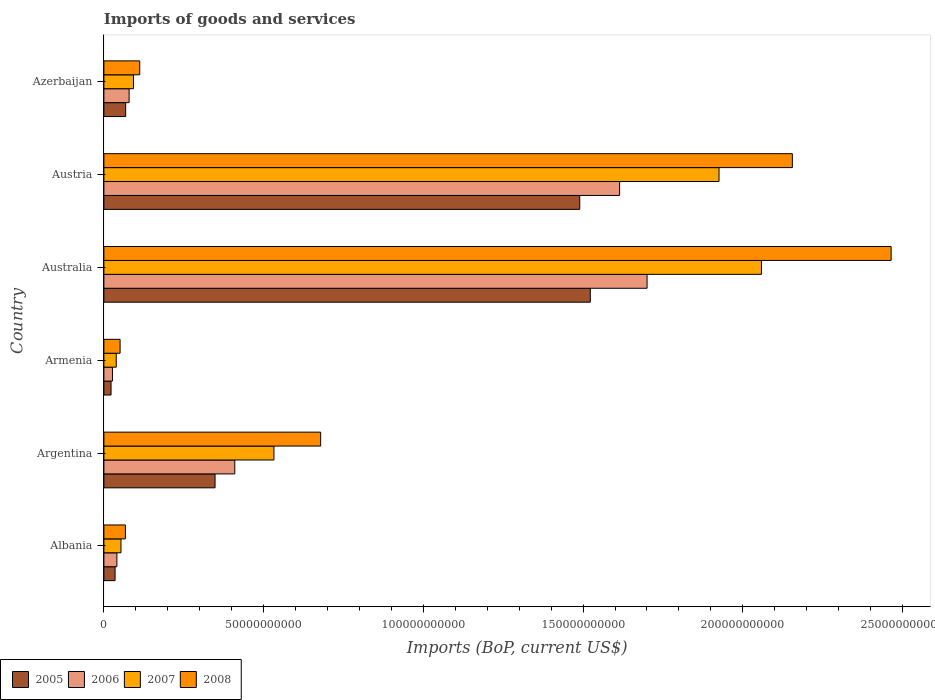How many different coloured bars are there?
Offer a very short reply. 4. How many groups of bars are there?
Offer a terse response. 6. Are the number of bars per tick equal to the number of legend labels?
Keep it short and to the point. Yes. Are the number of bars on each tick of the Y-axis equal?
Your answer should be very brief. Yes. How many bars are there on the 6th tick from the top?
Ensure brevity in your answer.  4. What is the label of the 4th group of bars from the top?
Make the answer very short. Armenia. In how many cases, is the number of bars for a given country not equal to the number of legend labels?
Provide a succinct answer. 0. What is the amount spent on imports in 2007 in Albania?
Make the answer very short. 5.34e+09. Across all countries, what is the maximum amount spent on imports in 2006?
Keep it short and to the point. 1.70e+11. Across all countries, what is the minimum amount spent on imports in 2005?
Keep it short and to the point. 2.24e+09. In which country was the amount spent on imports in 2005 minimum?
Make the answer very short. Armenia. What is the total amount spent on imports in 2007 in the graph?
Offer a terse response. 4.70e+11. What is the difference between the amount spent on imports in 2008 in Australia and that in Austria?
Provide a short and direct response. 3.09e+1. What is the difference between the amount spent on imports in 2005 in Azerbaijan and the amount spent on imports in 2007 in Armenia?
Your answer should be compact. 2.94e+09. What is the average amount spent on imports in 2007 per country?
Your answer should be very brief. 7.83e+1. What is the difference between the amount spent on imports in 2008 and amount spent on imports in 2007 in Azerbaijan?
Your response must be concise. 1.96e+09. What is the ratio of the amount spent on imports in 2005 in Albania to that in Armenia?
Your answer should be very brief. 1.56. What is the difference between the highest and the second highest amount spent on imports in 2006?
Offer a very short reply. 8.59e+09. What is the difference between the highest and the lowest amount spent on imports in 2007?
Provide a succinct answer. 2.02e+11. In how many countries, is the amount spent on imports in 2006 greater than the average amount spent on imports in 2006 taken over all countries?
Offer a very short reply. 2. Is the sum of the amount spent on imports in 2008 in Argentina and Armenia greater than the maximum amount spent on imports in 2007 across all countries?
Provide a succinct answer. No. Is it the case that in every country, the sum of the amount spent on imports in 2007 and amount spent on imports in 2008 is greater than the sum of amount spent on imports in 2006 and amount spent on imports in 2005?
Your answer should be very brief. No. What does the 2nd bar from the top in Albania represents?
Your answer should be very brief. 2007. Is it the case that in every country, the sum of the amount spent on imports in 2005 and amount spent on imports in 2007 is greater than the amount spent on imports in 2006?
Keep it short and to the point. Yes. Are all the bars in the graph horizontal?
Keep it short and to the point. Yes. Where does the legend appear in the graph?
Your response must be concise. Bottom left. What is the title of the graph?
Make the answer very short. Imports of goods and services. Does "1963" appear as one of the legend labels in the graph?
Your response must be concise. No. What is the label or title of the X-axis?
Provide a short and direct response. Imports (BoP, current US$). What is the label or title of the Y-axis?
Provide a short and direct response. Country. What is the Imports (BoP, current US$) in 2005 in Albania?
Keep it short and to the point. 3.50e+09. What is the Imports (BoP, current US$) in 2006 in Albania?
Ensure brevity in your answer.  4.07e+09. What is the Imports (BoP, current US$) of 2007 in Albania?
Provide a succinct answer. 5.34e+09. What is the Imports (BoP, current US$) in 2008 in Albania?
Provide a short and direct response. 6.73e+09. What is the Imports (BoP, current US$) of 2005 in Argentina?
Your answer should be compact. 3.48e+1. What is the Imports (BoP, current US$) of 2006 in Argentina?
Ensure brevity in your answer.  4.10e+1. What is the Imports (BoP, current US$) in 2007 in Argentina?
Give a very brief answer. 5.32e+1. What is the Imports (BoP, current US$) in 2008 in Argentina?
Offer a very short reply. 6.79e+1. What is the Imports (BoP, current US$) of 2005 in Armenia?
Keep it short and to the point. 2.24e+09. What is the Imports (BoP, current US$) in 2006 in Armenia?
Your response must be concise. 2.68e+09. What is the Imports (BoP, current US$) of 2007 in Armenia?
Ensure brevity in your answer.  3.88e+09. What is the Imports (BoP, current US$) in 2008 in Armenia?
Provide a succinct answer. 5.07e+09. What is the Imports (BoP, current US$) in 2005 in Australia?
Make the answer very short. 1.52e+11. What is the Imports (BoP, current US$) in 2006 in Australia?
Give a very brief answer. 1.70e+11. What is the Imports (BoP, current US$) in 2007 in Australia?
Provide a short and direct response. 2.06e+11. What is the Imports (BoP, current US$) of 2008 in Australia?
Offer a terse response. 2.46e+11. What is the Imports (BoP, current US$) in 2005 in Austria?
Your answer should be very brief. 1.49e+11. What is the Imports (BoP, current US$) in 2006 in Austria?
Your answer should be very brief. 1.61e+11. What is the Imports (BoP, current US$) of 2007 in Austria?
Offer a very short reply. 1.93e+11. What is the Imports (BoP, current US$) of 2008 in Austria?
Make the answer very short. 2.16e+11. What is the Imports (BoP, current US$) of 2005 in Azerbaijan?
Offer a very short reply. 6.81e+09. What is the Imports (BoP, current US$) of 2006 in Azerbaijan?
Offer a very short reply. 7.89e+09. What is the Imports (BoP, current US$) in 2007 in Azerbaijan?
Your response must be concise. 9.26e+09. What is the Imports (BoP, current US$) in 2008 in Azerbaijan?
Make the answer very short. 1.12e+1. Across all countries, what is the maximum Imports (BoP, current US$) of 2005?
Make the answer very short. 1.52e+11. Across all countries, what is the maximum Imports (BoP, current US$) in 2006?
Ensure brevity in your answer.  1.70e+11. Across all countries, what is the maximum Imports (BoP, current US$) in 2007?
Your answer should be compact. 2.06e+11. Across all countries, what is the maximum Imports (BoP, current US$) in 2008?
Your response must be concise. 2.46e+11. Across all countries, what is the minimum Imports (BoP, current US$) of 2005?
Provide a short and direct response. 2.24e+09. Across all countries, what is the minimum Imports (BoP, current US$) of 2006?
Offer a terse response. 2.68e+09. Across all countries, what is the minimum Imports (BoP, current US$) of 2007?
Ensure brevity in your answer.  3.88e+09. Across all countries, what is the minimum Imports (BoP, current US$) of 2008?
Offer a terse response. 5.07e+09. What is the total Imports (BoP, current US$) of 2005 in the graph?
Keep it short and to the point. 3.49e+11. What is the total Imports (BoP, current US$) in 2006 in the graph?
Offer a very short reply. 3.87e+11. What is the total Imports (BoP, current US$) of 2007 in the graph?
Ensure brevity in your answer.  4.70e+11. What is the total Imports (BoP, current US$) of 2008 in the graph?
Your response must be concise. 5.53e+11. What is the difference between the Imports (BoP, current US$) of 2005 in Albania and that in Argentina?
Your answer should be compact. -3.13e+1. What is the difference between the Imports (BoP, current US$) of 2006 in Albania and that in Argentina?
Ensure brevity in your answer.  -3.69e+1. What is the difference between the Imports (BoP, current US$) in 2007 in Albania and that in Argentina?
Your answer should be compact. -4.79e+1. What is the difference between the Imports (BoP, current US$) of 2008 in Albania and that in Argentina?
Your answer should be compact. -6.11e+1. What is the difference between the Imports (BoP, current US$) in 2005 in Albania and that in Armenia?
Your response must be concise. 1.26e+09. What is the difference between the Imports (BoP, current US$) in 2006 in Albania and that in Armenia?
Keep it short and to the point. 1.39e+09. What is the difference between the Imports (BoP, current US$) in 2007 in Albania and that in Armenia?
Offer a very short reply. 1.47e+09. What is the difference between the Imports (BoP, current US$) in 2008 in Albania and that in Armenia?
Make the answer very short. 1.66e+09. What is the difference between the Imports (BoP, current US$) of 2005 in Albania and that in Australia?
Give a very brief answer. -1.49e+11. What is the difference between the Imports (BoP, current US$) of 2006 in Albania and that in Australia?
Ensure brevity in your answer.  -1.66e+11. What is the difference between the Imports (BoP, current US$) of 2007 in Albania and that in Australia?
Your response must be concise. -2.00e+11. What is the difference between the Imports (BoP, current US$) in 2008 in Albania and that in Australia?
Provide a short and direct response. -2.40e+11. What is the difference between the Imports (BoP, current US$) in 2005 in Albania and that in Austria?
Your answer should be compact. -1.45e+11. What is the difference between the Imports (BoP, current US$) of 2006 in Albania and that in Austria?
Give a very brief answer. -1.57e+11. What is the difference between the Imports (BoP, current US$) in 2007 in Albania and that in Austria?
Provide a succinct answer. -1.87e+11. What is the difference between the Imports (BoP, current US$) in 2008 in Albania and that in Austria?
Your answer should be compact. -2.09e+11. What is the difference between the Imports (BoP, current US$) in 2005 in Albania and that in Azerbaijan?
Ensure brevity in your answer.  -3.31e+09. What is the difference between the Imports (BoP, current US$) of 2006 in Albania and that in Azerbaijan?
Keep it short and to the point. -3.82e+09. What is the difference between the Imports (BoP, current US$) of 2007 in Albania and that in Azerbaijan?
Offer a terse response. -3.92e+09. What is the difference between the Imports (BoP, current US$) of 2008 in Albania and that in Azerbaijan?
Give a very brief answer. -4.49e+09. What is the difference between the Imports (BoP, current US$) in 2005 in Argentina and that in Armenia?
Provide a short and direct response. 3.26e+1. What is the difference between the Imports (BoP, current US$) in 2006 in Argentina and that in Armenia?
Give a very brief answer. 3.83e+1. What is the difference between the Imports (BoP, current US$) of 2007 in Argentina and that in Armenia?
Provide a succinct answer. 4.94e+1. What is the difference between the Imports (BoP, current US$) in 2008 in Argentina and that in Armenia?
Offer a very short reply. 6.28e+1. What is the difference between the Imports (BoP, current US$) in 2005 in Argentina and that in Australia?
Provide a short and direct response. -1.17e+11. What is the difference between the Imports (BoP, current US$) in 2006 in Argentina and that in Australia?
Your answer should be very brief. -1.29e+11. What is the difference between the Imports (BoP, current US$) in 2007 in Argentina and that in Australia?
Your response must be concise. -1.53e+11. What is the difference between the Imports (BoP, current US$) of 2008 in Argentina and that in Australia?
Your response must be concise. -1.79e+11. What is the difference between the Imports (BoP, current US$) of 2005 in Argentina and that in Austria?
Provide a succinct answer. -1.14e+11. What is the difference between the Imports (BoP, current US$) of 2006 in Argentina and that in Austria?
Keep it short and to the point. -1.20e+11. What is the difference between the Imports (BoP, current US$) in 2007 in Argentina and that in Austria?
Your response must be concise. -1.39e+11. What is the difference between the Imports (BoP, current US$) in 2008 in Argentina and that in Austria?
Offer a very short reply. -1.48e+11. What is the difference between the Imports (BoP, current US$) in 2005 in Argentina and that in Azerbaijan?
Your response must be concise. 2.80e+1. What is the difference between the Imports (BoP, current US$) of 2006 in Argentina and that in Azerbaijan?
Give a very brief answer. 3.31e+1. What is the difference between the Imports (BoP, current US$) in 2007 in Argentina and that in Azerbaijan?
Keep it short and to the point. 4.40e+1. What is the difference between the Imports (BoP, current US$) of 2008 in Argentina and that in Azerbaijan?
Keep it short and to the point. 5.66e+1. What is the difference between the Imports (BoP, current US$) of 2005 in Armenia and that in Australia?
Provide a succinct answer. -1.50e+11. What is the difference between the Imports (BoP, current US$) of 2006 in Armenia and that in Australia?
Offer a very short reply. -1.67e+11. What is the difference between the Imports (BoP, current US$) in 2007 in Armenia and that in Australia?
Keep it short and to the point. -2.02e+11. What is the difference between the Imports (BoP, current US$) in 2008 in Armenia and that in Australia?
Provide a short and direct response. -2.41e+11. What is the difference between the Imports (BoP, current US$) in 2005 in Armenia and that in Austria?
Offer a very short reply. -1.47e+11. What is the difference between the Imports (BoP, current US$) of 2006 in Armenia and that in Austria?
Ensure brevity in your answer.  -1.59e+11. What is the difference between the Imports (BoP, current US$) of 2007 in Armenia and that in Austria?
Your response must be concise. -1.89e+11. What is the difference between the Imports (BoP, current US$) of 2008 in Armenia and that in Austria?
Provide a succinct answer. -2.10e+11. What is the difference between the Imports (BoP, current US$) in 2005 in Armenia and that in Azerbaijan?
Give a very brief answer. -4.57e+09. What is the difference between the Imports (BoP, current US$) of 2006 in Armenia and that in Azerbaijan?
Your answer should be very brief. -5.21e+09. What is the difference between the Imports (BoP, current US$) in 2007 in Armenia and that in Azerbaijan?
Provide a succinct answer. -5.39e+09. What is the difference between the Imports (BoP, current US$) of 2008 in Armenia and that in Azerbaijan?
Offer a very short reply. -6.15e+09. What is the difference between the Imports (BoP, current US$) in 2005 in Australia and that in Austria?
Your answer should be very brief. 3.31e+09. What is the difference between the Imports (BoP, current US$) of 2006 in Australia and that in Austria?
Offer a terse response. 8.59e+09. What is the difference between the Imports (BoP, current US$) of 2007 in Australia and that in Austria?
Make the answer very short. 1.33e+1. What is the difference between the Imports (BoP, current US$) of 2008 in Australia and that in Austria?
Offer a very short reply. 3.09e+1. What is the difference between the Imports (BoP, current US$) of 2005 in Australia and that in Azerbaijan?
Ensure brevity in your answer.  1.45e+11. What is the difference between the Imports (BoP, current US$) in 2006 in Australia and that in Azerbaijan?
Your answer should be very brief. 1.62e+11. What is the difference between the Imports (BoP, current US$) in 2007 in Australia and that in Azerbaijan?
Offer a terse response. 1.97e+11. What is the difference between the Imports (BoP, current US$) in 2008 in Australia and that in Azerbaijan?
Offer a very short reply. 2.35e+11. What is the difference between the Imports (BoP, current US$) of 2005 in Austria and that in Azerbaijan?
Ensure brevity in your answer.  1.42e+11. What is the difference between the Imports (BoP, current US$) of 2006 in Austria and that in Azerbaijan?
Your answer should be compact. 1.54e+11. What is the difference between the Imports (BoP, current US$) in 2007 in Austria and that in Azerbaijan?
Your answer should be compact. 1.83e+11. What is the difference between the Imports (BoP, current US$) in 2008 in Austria and that in Azerbaijan?
Offer a terse response. 2.04e+11. What is the difference between the Imports (BoP, current US$) in 2005 in Albania and the Imports (BoP, current US$) in 2006 in Argentina?
Give a very brief answer. -3.75e+1. What is the difference between the Imports (BoP, current US$) in 2005 in Albania and the Imports (BoP, current US$) in 2007 in Argentina?
Provide a short and direct response. -4.97e+1. What is the difference between the Imports (BoP, current US$) in 2005 in Albania and the Imports (BoP, current US$) in 2008 in Argentina?
Provide a succinct answer. -6.43e+1. What is the difference between the Imports (BoP, current US$) of 2006 in Albania and the Imports (BoP, current US$) of 2007 in Argentina?
Keep it short and to the point. -4.92e+1. What is the difference between the Imports (BoP, current US$) in 2006 in Albania and the Imports (BoP, current US$) in 2008 in Argentina?
Your answer should be compact. -6.38e+1. What is the difference between the Imports (BoP, current US$) in 2007 in Albania and the Imports (BoP, current US$) in 2008 in Argentina?
Provide a short and direct response. -6.25e+1. What is the difference between the Imports (BoP, current US$) in 2005 in Albania and the Imports (BoP, current US$) in 2006 in Armenia?
Ensure brevity in your answer.  8.18e+08. What is the difference between the Imports (BoP, current US$) of 2005 in Albania and the Imports (BoP, current US$) of 2007 in Armenia?
Your answer should be very brief. -3.75e+08. What is the difference between the Imports (BoP, current US$) of 2005 in Albania and the Imports (BoP, current US$) of 2008 in Armenia?
Offer a very short reply. -1.57e+09. What is the difference between the Imports (BoP, current US$) of 2006 in Albania and the Imports (BoP, current US$) of 2007 in Armenia?
Offer a terse response. 1.98e+08. What is the difference between the Imports (BoP, current US$) in 2006 in Albania and the Imports (BoP, current US$) in 2008 in Armenia?
Your answer should be very brief. -9.98e+08. What is the difference between the Imports (BoP, current US$) of 2007 in Albania and the Imports (BoP, current US$) of 2008 in Armenia?
Provide a short and direct response. 2.73e+08. What is the difference between the Imports (BoP, current US$) of 2005 in Albania and the Imports (BoP, current US$) of 2006 in Australia?
Provide a short and direct response. -1.67e+11. What is the difference between the Imports (BoP, current US$) in 2005 in Albania and the Imports (BoP, current US$) in 2007 in Australia?
Ensure brevity in your answer.  -2.02e+11. What is the difference between the Imports (BoP, current US$) of 2005 in Albania and the Imports (BoP, current US$) of 2008 in Australia?
Your answer should be very brief. -2.43e+11. What is the difference between the Imports (BoP, current US$) in 2006 in Albania and the Imports (BoP, current US$) in 2007 in Australia?
Offer a very short reply. -2.02e+11. What is the difference between the Imports (BoP, current US$) in 2006 in Albania and the Imports (BoP, current US$) in 2008 in Australia?
Offer a terse response. -2.42e+11. What is the difference between the Imports (BoP, current US$) of 2007 in Albania and the Imports (BoP, current US$) of 2008 in Australia?
Your answer should be very brief. -2.41e+11. What is the difference between the Imports (BoP, current US$) of 2005 in Albania and the Imports (BoP, current US$) of 2006 in Austria?
Provide a short and direct response. -1.58e+11. What is the difference between the Imports (BoP, current US$) of 2005 in Albania and the Imports (BoP, current US$) of 2007 in Austria?
Provide a short and direct response. -1.89e+11. What is the difference between the Imports (BoP, current US$) of 2005 in Albania and the Imports (BoP, current US$) of 2008 in Austria?
Give a very brief answer. -2.12e+11. What is the difference between the Imports (BoP, current US$) of 2006 in Albania and the Imports (BoP, current US$) of 2007 in Austria?
Provide a succinct answer. -1.88e+11. What is the difference between the Imports (BoP, current US$) of 2006 in Albania and the Imports (BoP, current US$) of 2008 in Austria?
Offer a terse response. -2.11e+11. What is the difference between the Imports (BoP, current US$) in 2007 in Albania and the Imports (BoP, current US$) in 2008 in Austria?
Your answer should be very brief. -2.10e+11. What is the difference between the Imports (BoP, current US$) in 2005 in Albania and the Imports (BoP, current US$) in 2006 in Azerbaijan?
Keep it short and to the point. -4.39e+09. What is the difference between the Imports (BoP, current US$) of 2005 in Albania and the Imports (BoP, current US$) of 2007 in Azerbaijan?
Your answer should be compact. -5.76e+09. What is the difference between the Imports (BoP, current US$) in 2005 in Albania and the Imports (BoP, current US$) in 2008 in Azerbaijan?
Your answer should be very brief. -7.72e+09. What is the difference between the Imports (BoP, current US$) in 2006 in Albania and the Imports (BoP, current US$) in 2007 in Azerbaijan?
Provide a short and direct response. -5.19e+09. What is the difference between the Imports (BoP, current US$) in 2006 in Albania and the Imports (BoP, current US$) in 2008 in Azerbaijan?
Your response must be concise. -7.15e+09. What is the difference between the Imports (BoP, current US$) of 2007 in Albania and the Imports (BoP, current US$) of 2008 in Azerbaijan?
Make the answer very short. -5.88e+09. What is the difference between the Imports (BoP, current US$) of 2005 in Argentina and the Imports (BoP, current US$) of 2006 in Armenia?
Offer a terse response. 3.21e+1. What is the difference between the Imports (BoP, current US$) in 2005 in Argentina and the Imports (BoP, current US$) in 2007 in Armenia?
Ensure brevity in your answer.  3.09e+1. What is the difference between the Imports (BoP, current US$) in 2005 in Argentina and the Imports (BoP, current US$) in 2008 in Armenia?
Your response must be concise. 2.97e+1. What is the difference between the Imports (BoP, current US$) in 2006 in Argentina and the Imports (BoP, current US$) in 2007 in Armenia?
Provide a short and direct response. 3.71e+1. What is the difference between the Imports (BoP, current US$) of 2006 in Argentina and the Imports (BoP, current US$) of 2008 in Armenia?
Your answer should be very brief. 3.59e+1. What is the difference between the Imports (BoP, current US$) of 2007 in Argentina and the Imports (BoP, current US$) of 2008 in Armenia?
Your response must be concise. 4.82e+1. What is the difference between the Imports (BoP, current US$) in 2005 in Argentina and the Imports (BoP, current US$) in 2006 in Australia?
Your response must be concise. -1.35e+11. What is the difference between the Imports (BoP, current US$) of 2005 in Argentina and the Imports (BoP, current US$) of 2007 in Australia?
Keep it short and to the point. -1.71e+11. What is the difference between the Imports (BoP, current US$) of 2005 in Argentina and the Imports (BoP, current US$) of 2008 in Australia?
Your answer should be very brief. -2.12e+11. What is the difference between the Imports (BoP, current US$) in 2006 in Argentina and the Imports (BoP, current US$) in 2007 in Australia?
Your answer should be very brief. -1.65e+11. What is the difference between the Imports (BoP, current US$) of 2006 in Argentina and the Imports (BoP, current US$) of 2008 in Australia?
Your answer should be compact. -2.05e+11. What is the difference between the Imports (BoP, current US$) in 2007 in Argentina and the Imports (BoP, current US$) in 2008 in Australia?
Make the answer very short. -1.93e+11. What is the difference between the Imports (BoP, current US$) of 2005 in Argentina and the Imports (BoP, current US$) of 2006 in Austria?
Provide a short and direct response. -1.27e+11. What is the difference between the Imports (BoP, current US$) in 2005 in Argentina and the Imports (BoP, current US$) in 2007 in Austria?
Your answer should be compact. -1.58e+11. What is the difference between the Imports (BoP, current US$) in 2005 in Argentina and the Imports (BoP, current US$) in 2008 in Austria?
Keep it short and to the point. -1.81e+11. What is the difference between the Imports (BoP, current US$) in 2006 in Argentina and the Imports (BoP, current US$) in 2007 in Austria?
Provide a short and direct response. -1.52e+11. What is the difference between the Imports (BoP, current US$) in 2006 in Argentina and the Imports (BoP, current US$) in 2008 in Austria?
Give a very brief answer. -1.75e+11. What is the difference between the Imports (BoP, current US$) in 2007 in Argentina and the Imports (BoP, current US$) in 2008 in Austria?
Your response must be concise. -1.62e+11. What is the difference between the Imports (BoP, current US$) in 2005 in Argentina and the Imports (BoP, current US$) in 2006 in Azerbaijan?
Make the answer very short. 2.69e+1. What is the difference between the Imports (BoP, current US$) in 2005 in Argentina and the Imports (BoP, current US$) in 2007 in Azerbaijan?
Your response must be concise. 2.55e+1. What is the difference between the Imports (BoP, current US$) of 2005 in Argentina and the Imports (BoP, current US$) of 2008 in Azerbaijan?
Keep it short and to the point. 2.36e+1. What is the difference between the Imports (BoP, current US$) of 2006 in Argentina and the Imports (BoP, current US$) of 2007 in Azerbaijan?
Keep it short and to the point. 3.17e+1. What is the difference between the Imports (BoP, current US$) in 2006 in Argentina and the Imports (BoP, current US$) in 2008 in Azerbaijan?
Offer a very short reply. 2.98e+1. What is the difference between the Imports (BoP, current US$) of 2007 in Argentina and the Imports (BoP, current US$) of 2008 in Azerbaijan?
Give a very brief answer. 4.20e+1. What is the difference between the Imports (BoP, current US$) of 2005 in Armenia and the Imports (BoP, current US$) of 2006 in Australia?
Offer a very short reply. -1.68e+11. What is the difference between the Imports (BoP, current US$) of 2005 in Armenia and the Imports (BoP, current US$) of 2007 in Australia?
Give a very brief answer. -2.04e+11. What is the difference between the Imports (BoP, current US$) of 2005 in Armenia and the Imports (BoP, current US$) of 2008 in Australia?
Offer a very short reply. -2.44e+11. What is the difference between the Imports (BoP, current US$) in 2006 in Armenia and the Imports (BoP, current US$) in 2007 in Australia?
Keep it short and to the point. -2.03e+11. What is the difference between the Imports (BoP, current US$) of 2006 in Armenia and the Imports (BoP, current US$) of 2008 in Australia?
Provide a short and direct response. -2.44e+11. What is the difference between the Imports (BoP, current US$) in 2007 in Armenia and the Imports (BoP, current US$) in 2008 in Australia?
Your answer should be very brief. -2.43e+11. What is the difference between the Imports (BoP, current US$) in 2005 in Armenia and the Imports (BoP, current US$) in 2006 in Austria?
Offer a terse response. -1.59e+11. What is the difference between the Imports (BoP, current US$) in 2005 in Armenia and the Imports (BoP, current US$) in 2007 in Austria?
Offer a very short reply. -1.90e+11. What is the difference between the Imports (BoP, current US$) of 2005 in Armenia and the Imports (BoP, current US$) of 2008 in Austria?
Your answer should be very brief. -2.13e+11. What is the difference between the Imports (BoP, current US$) of 2006 in Armenia and the Imports (BoP, current US$) of 2007 in Austria?
Keep it short and to the point. -1.90e+11. What is the difference between the Imports (BoP, current US$) of 2006 in Armenia and the Imports (BoP, current US$) of 2008 in Austria?
Your answer should be compact. -2.13e+11. What is the difference between the Imports (BoP, current US$) of 2007 in Armenia and the Imports (BoP, current US$) of 2008 in Austria?
Your answer should be compact. -2.12e+11. What is the difference between the Imports (BoP, current US$) of 2005 in Armenia and the Imports (BoP, current US$) of 2006 in Azerbaijan?
Ensure brevity in your answer.  -5.65e+09. What is the difference between the Imports (BoP, current US$) in 2005 in Armenia and the Imports (BoP, current US$) in 2007 in Azerbaijan?
Give a very brief answer. -7.02e+09. What is the difference between the Imports (BoP, current US$) of 2005 in Armenia and the Imports (BoP, current US$) of 2008 in Azerbaijan?
Offer a very short reply. -8.98e+09. What is the difference between the Imports (BoP, current US$) in 2006 in Armenia and the Imports (BoP, current US$) in 2007 in Azerbaijan?
Your answer should be compact. -6.58e+09. What is the difference between the Imports (BoP, current US$) in 2006 in Armenia and the Imports (BoP, current US$) in 2008 in Azerbaijan?
Keep it short and to the point. -8.54e+09. What is the difference between the Imports (BoP, current US$) in 2007 in Armenia and the Imports (BoP, current US$) in 2008 in Azerbaijan?
Give a very brief answer. -7.35e+09. What is the difference between the Imports (BoP, current US$) of 2005 in Australia and the Imports (BoP, current US$) of 2006 in Austria?
Make the answer very short. -9.18e+09. What is the difference between the Imports (BoP, current US$) of 2005 in Australia and the Imports (BoP, current US$) of 2007 in Austria?
Provide a short and direct response. -4.03e+1. What is the difference between the Imports (BoP, current US$) in 2005 in Australia and the Imports (BoP, current US$) in 2008 in Austria?
Give a very brief answer. -6.32e+1. What is the difference between the Imports (BoP, current US$) in 2006 in Australia and the Imports (BoP, current US$) in 2007 in Austria?
Provide a succinct answer. -2.25e+1. What is the difference between the Imports (BoP, current US$) in 2006 in Australia and the Imports (BoP, current US$) in 2008 in Austria?
Offer a terse response. -4.55e+1. What is the difference between the Imports (BoP, current US$) of 2007 in Australia and the Imports (BoP, current US$) of 2008 in Austria?
Keep it short and to the point. -9.68e+09. What is the difference between the Imports (BoP, current US$) in 2005 in Australia and the Imports (BoP, current US$) in 2006 in Azerbaijan?
Give a very brief answer. 1.44e+11. What is the difference between the Imports (BoP, current US$) in 2005 in Australia and the Imports (BoP, current US$) in 2007 in Azerbaijan?
Give a very brief answer. 1.43e+11. What is the difference between the Imports (BoP, current US$) in 2005 in Australia and the Imports (BoP, current US$) in 2008 in Azerbaijan?
Your answer should be compact. 1.41e+11. What is the difference between the Imports (BoP, current US$) in 2006 in Australia and the Imports (BoP, current US$) in 2007 in Azerbaijan?
Your response must be concise. 1.61e+11. What is the difference between the Imports (BoP, current US$) in 2006 in Australia and the Imports (BoP, current US$) in 2008 in Azerbaijan?
Offer a terse response. 1.59e+11. What is the difference between the Imports (BoP, current US$) in 2007 in Australia and the Imports (BoP, current US$) in 2008 in Azerbaijan?
Your response must be concise. 1.95e+11. What is the difference between the Imports (BoP, current US$) in 2005 in Austria and the Imports (BoP, current US$) in 2006 in Azerbaijan?
Give a very brief answer. 1.41e+11. What is the difference between the Imports (BoP, current US$) in 2005 in Austria and the Imports (BoP, current US$) in 2007 in Azerbaijan?
Provide a succinct answer. 1.40e+11. What is the difference between the Imports (BoP, current US$) of 2005 in Austria and the Imports (BoP, current US$) of 2008 in Azerbaijan?
Offer a terse response. 1.38e+11. What is the difference between the Imports (BoP, current US$) of 2006 in Austria and the Imports (BoP, current US$) of 2007 in Azerbaijan?
Give a very brief answer. 1.52e+11. What is the difference between the Imports (BoP, current US$) of 2006 in Austria and the Imports (BoP, current US$) of 2008 in Azerbaijan?
Your response must be concise. 1.50e+11. What is the difference between the Imports (BoP, current US$) in 2007 in Austria and the Imports (BoP, current US$) in 2008 in Azerbaijan?
Offer a terse response. 1.81e+11. What is the average Imports (BoP, current US$) of 2005 per country?
Make the answer very short. 5.81e+1. What is the average Imports (BoP, current US$) in 2006 per country?
Provide a succinct answer. 6.45e+1. What is the average Imports (BoP, current US$) of 2007 per country?
Provide a succinct answer. 7.83e+1. What is the average Imports (BoP, current US$) of 2008 per country?
Ensure brevity in your answer.  9.21e+1. What is the difference between the Imports (BoP, current US$) of 2005 and Imports (BoP, current US$) of 2006 in Albania?
Make the answer very short. -5.73e+08. What is the difference between the Imports (BoP, current US$) in 2005 and Imports (BoP, current US$) in 2007 in Albania?
Your response must be concise. -1.84e+09. What is the difference between the Imports (BoP, current US$) in 2005 and Imports (BoP, current US$) in 2008 in Albania?
Provide a succinct answer. -3.23e+09. What is the difference between the Imports (BoP, current US$) of 2006 and Imports (BoP, current US$) of 2007 in Albania?
Your response must be concise. -1.27e+09. What is the difference between the Imports (BoP, current US$) in 2006 and Imports (BoP, current US$) in 2008 in Albania?
Make the answer very short. -2.66e+09. What is the difference between the Imports (BoP, current US$) of 2007 and Imports (BoP, current US$) of 2008 in Albania?
Make the answer very short. -1.39e+09. What is the difference between the Imports (BoP, current US$) of 2005 and Imports (BoP, current US$) of 2006 in Argentina?
Make the answer very short. -6.18e+09. What is the difference between the Imports (BoP, current US$) of 2005 and Imports (BoP, current US$) of 2007 in Argentina?
Your answer should be compact. -1.84e+1. What is the difference between the Imports (BoP, current US$) of 2005 and Imports (BoP, current US$) of 2008 in Argentina?
Give a very brief answer. -3.31e+1. What is the difference between the Imports (BoP, current US$) of 2006 and Imports (BoP, current US$) of 2007 in Argentina?
Your answer should be very brief. -1.23e+1. What is the difference between the Imports (BoP, current US$) in 2006 and Imports (BoP, current US$) in 2008 in Argentina?
Offer a terse response. -2.69e+1. What is the difference between the Imports (BoP, current US$) of 2007 and Imports (BoP, current US$) of 2008 in Argentina?
Offer a terse response. -1.46e+1. What is the difference between the Imports (BoP, current US$) in 2005 and Imports (BoP, current US$) in 2006 in Armenia?
Offer a terse response. -4.41e+08. What is the difference between the Imports (BoP, current US$) in 2005 and Imports (BoP, current US$) in 2007 in Armenia?
Provide a short and direct response. -1.63e+09. What is the difference between the Imports (BoP, current US$) in 2005 and Imports (BoP, current US$) in 2008 in Armenia?
Offer a terse response. -2.83e+09. What is the difference between the Imports (BoP, current US$) in 2006 and Imports (BoP, current US$) in 2007 in Armenia?
Your answer should be very brief. -1.19e+09. What is the difference between the Imports (BoP, current US$) in 2006 and Imports (BoP, current US$) in 2008 in Armenia?
Offer a terse response. -2.39e+09. What is the difference between the Imports (BoP, current US$) of 2007 and Imports (BoP, current US$) of 2008 in Armenia?
Your answer should be very brief. -1.20e+09. What is the difference between the Imports (BoP, current US$) in 2005 and Imports (BoP, current US$) in 2006 in Australia?
Keep it short and to the point. -1.78e+1. What is the difference between the Imports (BoP, current US$) of 2005 and Imports (BoP, current US$) of 2007 in Australia?
Give a very brief answer. -5.36e+1. What is the difference between the Imports (BoP, current US$) of 2005 and Imports (BoP, current US$) of 2008 in Australia?
Your answer should be very brief. -9.42e+1. What is the difference between the Imports (BoP, current US$) in 2006 and Imports (BoP, current US$) in 2007 in Australia?
Your answer should be compact. -3.58e+1. What is the difference between the Imports (BoP, current US$) in 2006 and Imports (BoP, current US$) in 2008 in Australia?
Ensure brevity in your answer.  -7.64e+1. What is the difference between the Imports (BoP, current US$) of 2007 and Imports (BoP, current US$) of 2008 in Australia?
Your answer should be compact. -4.06e+1. What is the difference between the Imports (BoP, current US$) of 2005 and Imports (BoP, current US$) of 2006 in Austria?
Offer a very short reply. -1.25e+1. What is the difference between the Imports (BoP, current US$) in 2005 and Imports (BoP, current US$) in 2007 in Austria?
Your answer should be compact. -4.36e+1. What is the difference between the Imports (BoP, current US$) in 2005 and Imports (BoP, current US$) in 2008 in Austria?
Your answer should be very brief. -6.66e+1. What is the difference between the Imports (BoP, current US$) in 2006 and Imports (BoP, current US$) in 2007 in Austria?
Your answer should be very brief. -3.11e+1. What is the difference between the Imports (BoP, current US$) of 2006 and Imports (BoP, current US$) of 2008 in Austria?
Offer a very short reply. -5.41e+1. What is the difference between the Imports (BoP, current US$) of 2007 and Imports (BoP, current US$) of 2008 in Austria?
Provide a succinct answer. -2.30e+1. What is the difference between the Imports (BoP, current US$) in 2005 and Imports (BoP, current US$) in 2006 in Azerbaijan?
Make the answer very short. -1.08e+09. What is the difference between the Imports (BoP, current US$) in 2005 and Imports (BoP, current US$) in 2007 in Azerbaijan?
Offer a terse response. -2.45e+09. What is the difference between the Imports (BoP, current US$) of 2005 and Imports (BoP, current US$) of 2008 in Azerbaijan?
Ensure brevity in your answer.  -4.41e+09. What is the difference between the Imports (BoP, current US$) in 2006 and Imports (BoP, current US$) in 2007 in Azerbaijan?
Ensure brevity in your answer.  -1.37e+09. What is the difference between the Imports (BoP, current US$) in 2006 and Imports (BoP, current US$) in 2008 in Azerbaijan?
Your answer should be very brief. -3.33e+09. What is the difference between the Imports (BoP, current US$) in 2007 and Imports (BoP, current US$) in 2008 in Azerbaijan?
Keep it short and to the point. -1.96e+09. What is the ratio of the Imports (BoP, current US$) of 2005 in Albania to that in Argentina?
Your answer should be very brief. 0.1. What is the ratio of the Imports (BoP, current US$) in 2006 in Albania to that in Argentina?
Keep it short and to the point. 0.1. What is the ratio of the Imports (BoP, current US$) in 2007 in Albania to that in Argentina?
Keep it short and to the point. 0.1. What is the ratio of the Imports (BoP, current US$) in 2008 in Albania to that in Argentina?
Your answer should be compact. 0.1. What is the ratio of the Imports (BoP, current US$) in 2005 in Albania to that in Armenia?
Ensure brevity in your answer.  1.56. What is the ratio of the Imports (BoP, current US$) in 2006 in Albania to that in Armenia?
Your answer should be compact. 1.52. What is the ratio of the Imports (BoP, current US$) of 2007 in Albania to that in Armenia?
Offer a terse response. 1.38. What is the ratio of the Imports (BoP, current US$) of 2008 in Albania to that in Armenia?
Ensure brevity in your answer.  1.33. What is the ratio of the Imports (BoP, current US$) in 2005 in Albania to that in Australia?
Ensure brevity in your answer.  0.02. What is the ratio of the Imports (BoP, current US$) of 2006 in Albania to that in Australia?
Offer a very short reply. 0.02. What is the ratio of the Imports (BoP, current US$) of 2007 in Albania to that in Australia?
Offer a very short reply. 0.03. What is the ratio of the Imports (BoP, current US$) of 2008 in Albania to that in Australia?
Offer a very short reply. 0.03. What is the ratio of the Imports (BoP, current US$) in 2005 in Albania to that in Austria?
Your answer should be very brief. 0.02. What is the ratio of the Imports (BoP, current US$) of 2006 in Albania to that in Austria?
Your response must be concise. 0.03. What is the ratio of the Imports (BoP, current US$) in 2007 in Albania to that in Austria?
Your answer should be very brief. 0.03. What is the ratio of the Imports (BoP, current US$) in 2008 in Albania to that in Austria?
Provide a short and direct response. 0.03. What is the ratio of the Imports (BoP, current US$) of 2005 in Albania to that in Azerbaijan?
Offer a terse response. 0.51. What is the ratio of the Imports (BoP, current US$) in 2006 in Albania to that in Azerbaijan?
Your answer should be very brief. 0.52. What is the ratio of the Imports (BoP, current US$) of 2007 in Albania to that in Azerbaijan?
Your answer should be compact. 0.58. What is the ratio of the Imports (BoP, current US$) in 2008 in Albania to that in Azerbaijan?
Provide a short and direct response. 0.6. What is the ratio of the Imports (BoP, current US$) in 2005 in Argentina to that in Armenia?
Make the answer very short. 15.52. What is the ratio of the Imports (BoP, current US$) of 2006 in Argentina to that in Armenia?
Your answer should be compact. 15.28. What is the ratio of the Imports (BoP, current US$) in 2007 in Argentina to that in Armenia?
Your answer should be compact. 13.73. What is the ratio of the Imports (BoP, current US$) in 2008 in Argentina to that in Armenia?
Your response must be concise. 13.38. What is the ratio of the Imports (BoP, current US$) of 2005 in Argentina to that in Australia?
Your response must be concise. 0.23. What is the ratio of the Imports (BoP, current US$) in 2006 in Argentina to that in Australia?
Provide a short and direct response. 0.24. What is the ratio of the Imports (BoP, current US$) in 2007 in Argentina to that in Australia?
Give a very brief answer. 0.26. What is the ratio of the Imports (BoP, current US$) of 2008 in Argentina to that in Australia?
Keep it short and to the point. 0.28. What is the ratio of the Imports (BoP, current US$) of 2005 in Argentina to that in Austria?
Provide a succinct answer. 0.23. What is the ratio of the Imports (BoP, current US$) in 2006 in Argentina to that in Austria?
Ensure brevity in your answer.  0.25. What is the ratio of the Imports (BoP, current US$) in 2007 in Argentina to that in Austria?
Give a very brief answer. 0.28. What is the ratio of the Imports (BoP, current US$) in 2008 in Argentina to that in Austria?
Ensure brevity in your answer.  0.31. What is the ratio of the Imports (BoP, current US$) in 2005 in Argentina to that in Azerbaijan?
Make the answer very short. 5.11. What is the ratio of the Imports (BoP, current US$) in 2006 in Argentina to that in Azerbaijan?
Provide a succinct answer. 5.19. What is the ratio of the Imports (BoP, current US$) in 2007 in Argentina to that in Azerbaijan?
Your response must be concise. 5.75. What is the ratio of the Imports (BoP, current US$) of 2008 in Argentina to that in Azerbaijan?
Ensure brevity in your answer.  6.05. What is the ratio of the Imports (BoP, current US$) in 2005 in Armenia to that in Australia?
Keep it short and to the point. 0.01. What is the ratio of the Imports (BoP, current US$) of 2006 in Armenia to that in Australia?
Your answer should be compact. 0.02. What is the ratio of the Imports (BoP, current US$) in 2007 in Armenia to that in Australia?
Make the answer very short. 0.02. What is the ratio of the Imports (BoP, current US$) in 2008 in Armenia to that in Australia?
Provide a succinct answer. 0.02. What is the ratio of the Imports (BoP, current US$) of 2005 in Armenia to that in Austria?
Provide a short and direct response. 0.01. What is the ratio of the Imports (BoP, current US$) of 2006 in Armenia to that in Austria?
Your response must be concise. 0.02. What is the ratio of the Imports (BoP, current US$) in 2007 in Armenia to that in Austria?
Your response must be concise. 0.02. What is the ratio of the Imports (BoP, current US$) in 2008 in Armenia to that in Austria?
Keep it short and to the point. 0.02. What is the ratio of the Imports (BoP, current US$) in 2005 in Armenia to that in Azerbaijan?
Your answer should be compact. 0.33. What is the ratio of the Imports (BoP, current US$) in 2006 in Armenia to that in Azerbaijan?
Offer a very short reply. 0.34. What is the ratio of the Imports (BoP, current US$) of 2007 in Armenia to that in Azerbaijan?
Provide a short and direct response. 0.42. What is the ratio of the Imports (BoP, current US$) in 2008 in Armenia to that in Azerbaijan?
Your answer should be compact. 0.45. What is the ratio of the Imports (BoP, current US$) of 2005 in Australia to that in Austria?
Give a very brief answer. 1.02. What is the ratio of the Imports (BoP, current US$) of 2006 in Australia to that in Austria?
Provide a short and direct response. 1.05. What is the ratio of the Imports (BoP, current US$) in 2007 in Australia to that in Austria?
Your response must be concise. 1.07. What is the ratio of the Imports (BoP, current US$) in 2008 in Australia to that in Austria?
Your response must be concise. 1.14. What is the ratio of the Imports (BoP, current US$) of 2005 in Australia to that in Azerbaijan?
Offer a very short reply. 22.36. What is the ratio of the Imports (BoP, current US$) in 2006 in Australia to that in Azerbaijan?
Offer a very short reply. 21.54. What is the ratio of the Imports (BoP, current US$) in 2007 in Australia to that in Azerbaijan?
Make the answer very short. 22.22. What is the ratio of the Imports (BoP, current US$) in 2008 in Australia to that in Azerbaijan?
Keep it short and to the point. 21.96. What is the ratio of the Imports (BoP, current US$) of 2005 in Austria to that in Azerbaijan?
Give a very brief answer. 21.87. What is the ratio of the Imports (BoP, current US$) of 2006 in Austria to that in Azerbaijan?
Your answer should be compact. 20.45. What is the ratio of the Imports (BoP, current US$) in 2007 in Austria to that in Azerbaijan?
Offer a very short reply. 20.79. What is the ratio of the Imports (BoP, current US$) in 2008 in Austria to that in Azerbaijan?
Your answer should be very brief. 19.21. What is the difference between the highest and the second highest Imports (BoP, current US$) in 2005?
Give a very brief answer. 3.31e+09. What is the difference between the highest and the second highest Imports (BoP, current US$) in 2006?
Your answer should be compact. 8.59e+09. What is the difference between the highest and the second highest Imports (BoP, current US$) in 2007?
Your response must be concise. 1.33e+1. What is the difference between the highest and the second highest Imports (BoP, current US$) in 2008?
Keep it short and to the point. 3.09e+1. What is the difference between the highest and the lowest Imports (BoP, current US$) of 2005?
Keep it short and to the point. 1.50e+11. What is the difference between the highest and the lowest Imports (BoP, current US$) of 2006?
Provide a short and direct response. 1.67e+11. What is the difference between the highest and the lowest Imports (BoP, current US$) of 2007?
Offer a very short reply. 2.02e+11. What is the difference between the highest and the lowest Imports (BoP, current US$) of 2008?
Make the answer very short. 2.41e+11. 